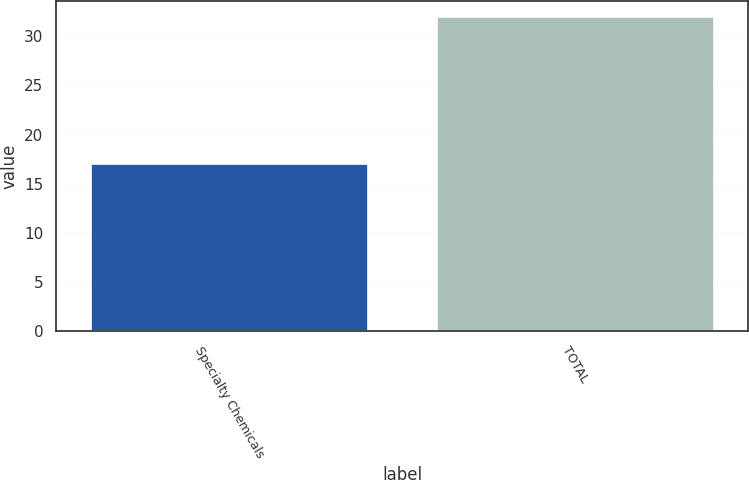Convert chart. <chart><loc_0><loc_0><loc_500><loc_500><bar_chart><fcel>Specialty Chemicals<fcel>TOTAL<nl><fcel>17<fcel>32<nl></chart> 